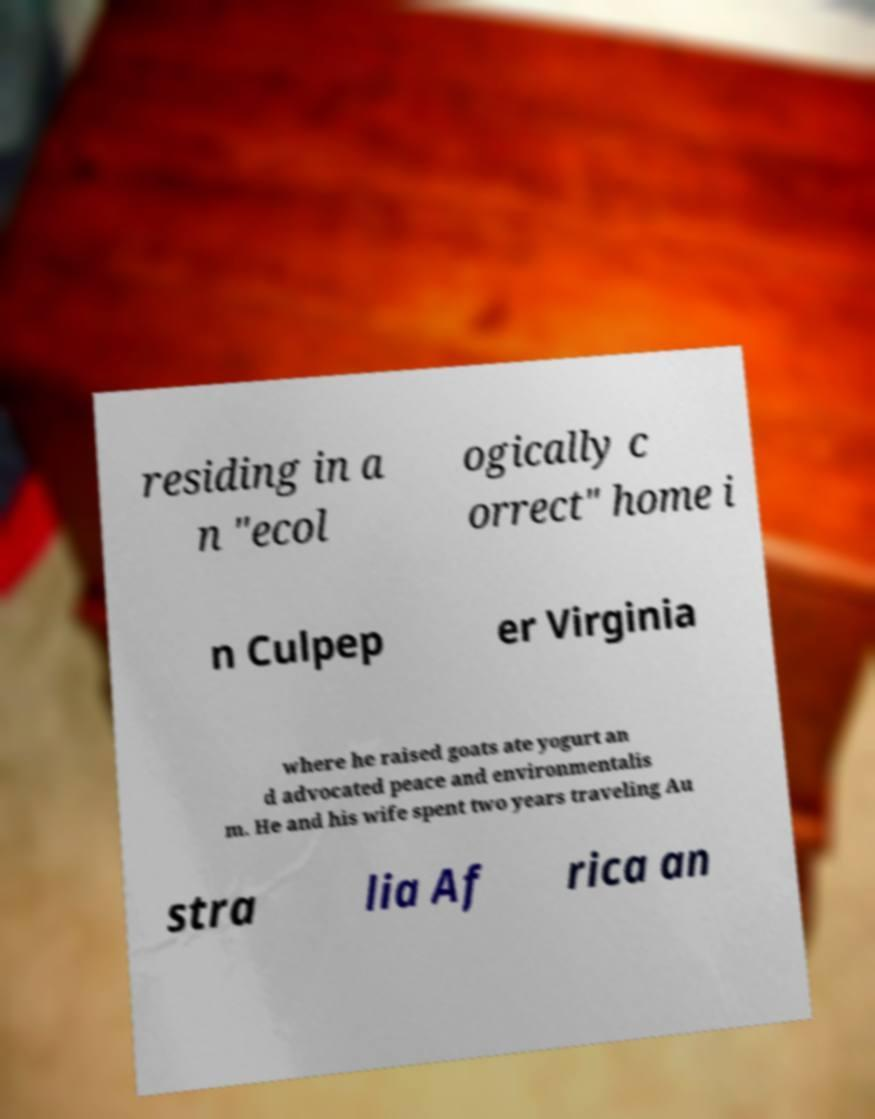Please read and relay the text visible in this image. What does it say? residing in a n "ecol ogically c orrect" home i n Culpep er Virginia where he raised goats ate yogurt an d advocated peace and environmentalis m. He and his wife spent two years traveling Au stra lia Af rica an 